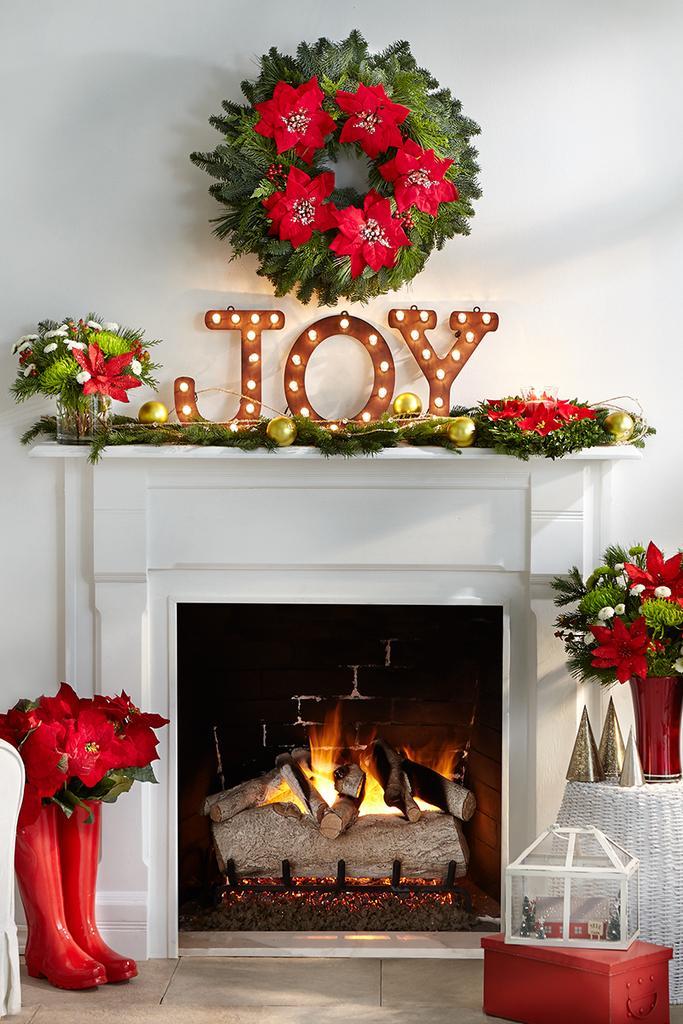How would you summarize this image in a sentence or two? In this image, we can see a fireplace and there are flower vases, boxes, alphabets with lights and there are some decor items. At the bottom, there is a floor. 